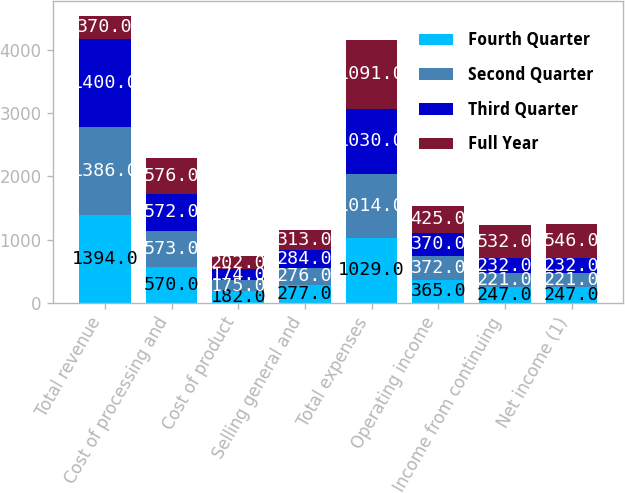Convert chart to OTSL. <chart><loc_0><loc_0><loc_500><loc_500><stacked_bar_chart><ecel><fcel>Total revenue<fcel>Cost of processing and<fcel>Cost of product<fcel>Selling general and<fcel>Total expenses<fcel>Operating income<fcel>Income from continuing<fcel>Net income (1)<nl><fcel>Fourth Quarter<fcel>1394<fcel>570<fcel>182<fcel>277<fcel>1029<fcel>365<fcel>247<fcel>247<nl><fcel>Second Quarter<fcel>1386<fcel>573<fcel>175<fcel>276<fcel>1014<fcel>372<fcel>221<fcel>221<nl><fcel>Third Quarter<fcel>1400<fcel>572<fcel>174<fcel>284<fcel>1030<fcel>370<fcel>232<fcel>232<nl><fcel>Full Year<fcel>370<fcel>576<fcel>202<fcel>313<fcel>1091<fcel>425<fcel>532<fcel>546<nl></chart> 